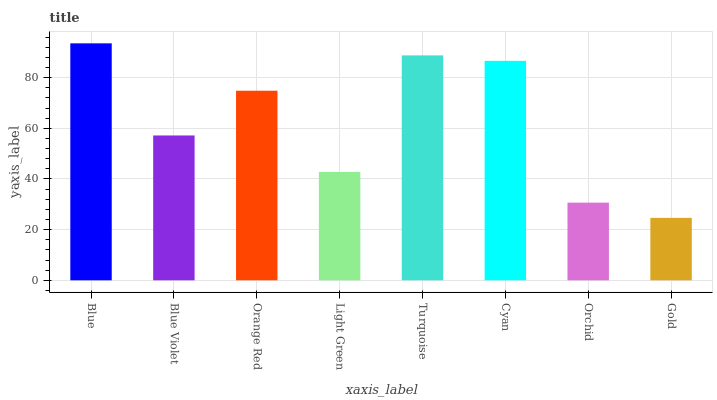Is Gold the minimum?
Answer yes or no. Yes. Is Blue the maximum?
Answer yes or no. Yes. Is Blue Violet the minimum?
Answer yes or no. No. Is Blue Violet the maximum?
Answer yes or no. No. Is Blue greater than Blue Violet?
Answer yes or no. Yes. Is Blue Violet less than Blue?
Answer yes or no. Yes. Is Blue Violet greater than Blue?
Answer yes or no. No. Is Blue less than Blue Violet?
Answer yes or no. No. Is Orange Red the high median?
Answer yes or no. Yes. Is Blue Violet the low median?
Answer yes or no. Yes. Is Blue Violet the high median?
Answer yes or no. No. Is Gold the low median?
Answer yes or no. No. 